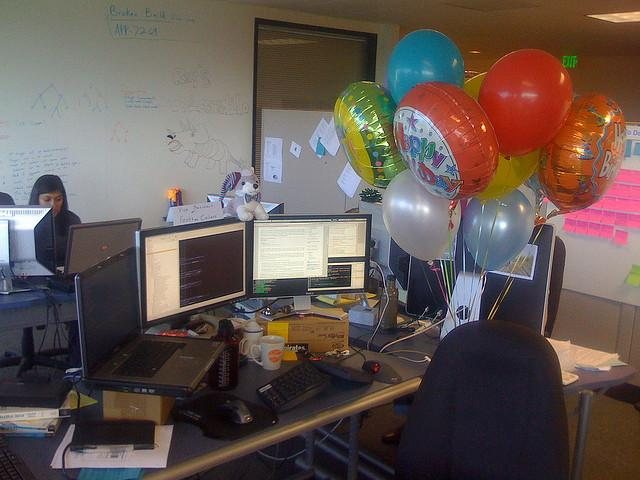What sort of wax item might be on a dessert enjoyed by the person sitting by the balloons today? candle 